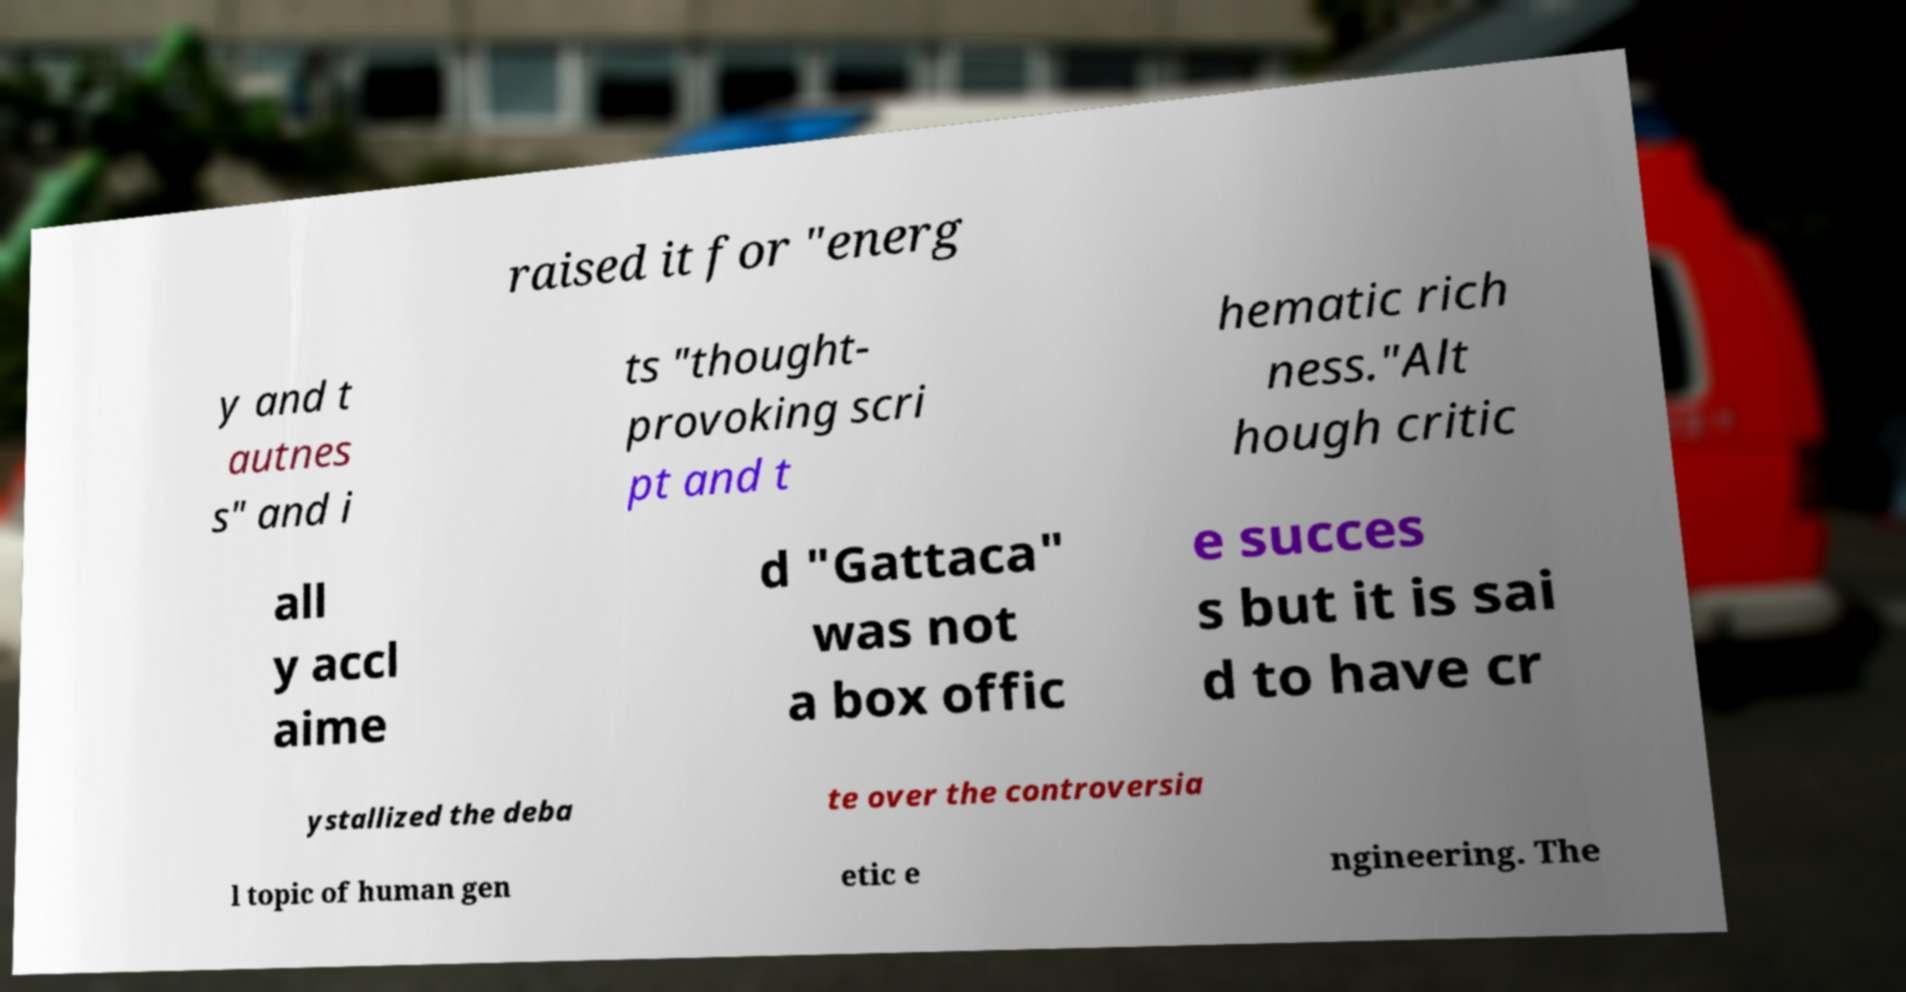For documentation purposes, I need the text within this image transcribed. Could you provide that? raised it for "energ y and t autnes s" and i ts "thought- provoking scri pt and t hematic rich ness."Alt hough critic all y accl aime d "Gattaca" was not a box offic e succes s but it is sai d to have cr ystallized the deba te over the controversia l topic of human gen etic e ngineering. The 